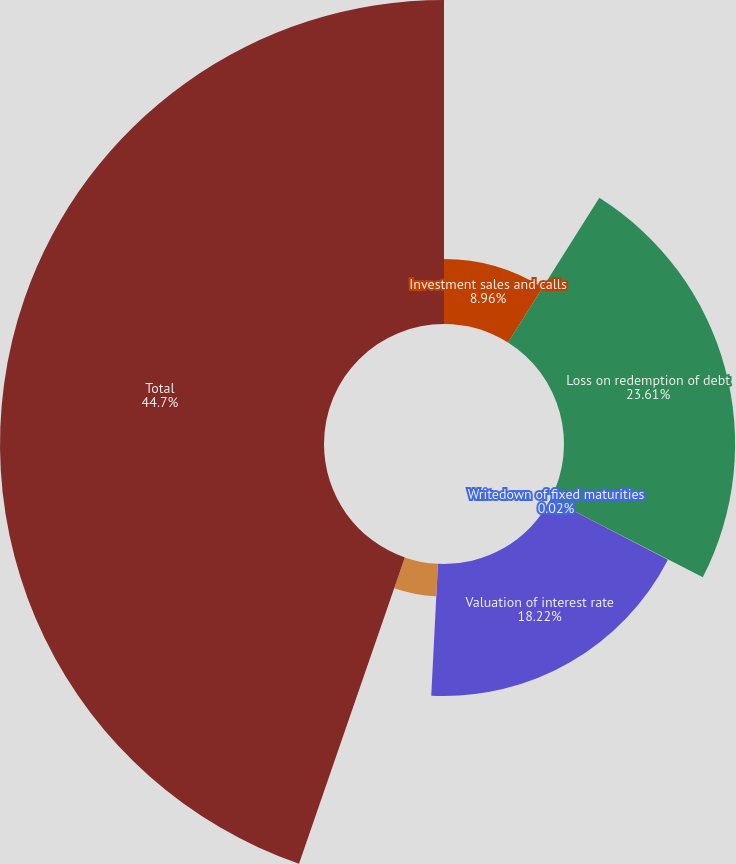Convert chart to OTSL. <chart><loc_0><loc_0><loc_500><loc_500><pie_chart><fcel>Investment sales and calls<fcel>Loss on redemption of debt<fcel>Writedown of fixed maturities<fcel>Valuation of interest rate<fcel>Spread on interest rate swaps<fcel>Total<nl><fcel>8.96%<fcel>23.61%<fcel>0.02%<fcel>18.22%<fcel>4.49%<fcel>44.71%<nl></chart> 